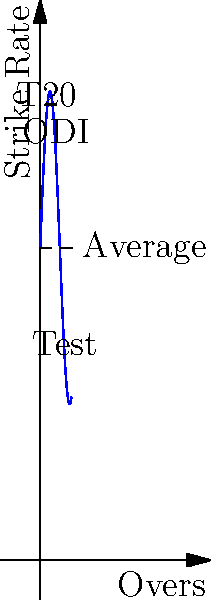The graph shows Yuvraj Singh's strike rate across different match formats (T20, ODI, and Test) over a theoretical 10-over span. The strike rate is given by the function $S(x) = 100 + 50\sin(\frac{x}{2})$, where $x$ represents the over number. Calculate the area between Yuvraj's strike rate curve and the average strike rate line (100) from over 0 to over 10. To find the area between Yuvraj's strike rate curve and the average line, we need to:

1. Set up the integral:
   Area = $\int_0^{10} |S(x) - 100| dx = \int_0^{10} |50\sin(\frac{x}{2})| dx$

2. Since $\sin(\frac{x}{2})$ oscillates between -1 and 1, we need to split the integral at the points where $\sin(\frac{x}{2}) = 0$:
   $x = 0, 2\pi, 4\pi, ...$

3. In the range [0, 10], we have:
   $\int_0^{2\pi} 50\sin(\frac{x}{2}) dx - \int_{2\pi}^{4\pi} 50\sin(\frac{x}{2}) dx + \int_{4\pi}^{10} 50\sin(\frac{x}{2}) dx$

4. Integrate each part:
   $[-100\cos(\frac{x}{2})]_0^{2\pi} - [-100\cos(\frac{x}{2})]_{2\pi}^{4\pi} + [-100\cos(\frac{x}{2})]_{4\pi}^{10}$

5. Evaluate:
   $(100 - (-100)) - (-100 - 100) + (-100\cos(5) - 100)$
   $= 200 + 200 - 100(\cos(5) + 1)$

6. Simplify:
   $= 400 - 100(\cos(5) + 1) \approx 305.98$
Answer: $305.98$ square units 